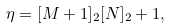<formula> <loc_0><loc_0><loc_500><loc_500>\eta = [ M + 1 ] _ { 2 } [ N ] _ { 2 } + 1 ,</formula> 